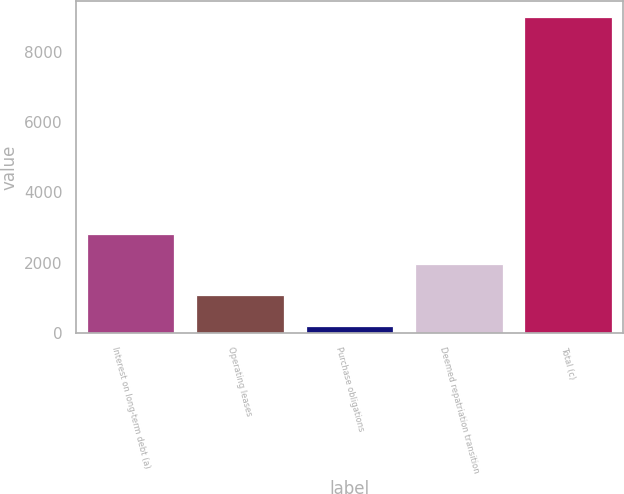Convert chart. <chart><loc_0><loc_0><loc_500><loc_500><bar_chart><fcel>Interest on long-term debt (a)<fcel>Operating leases<fcel>Purchase obligations<fcel>Deemed repatriation transition<fcel>Total (c)<nl><fcel>2830<fcel>1064<fcel>181<fcel>1947<fcel>9011<nl></chart> 